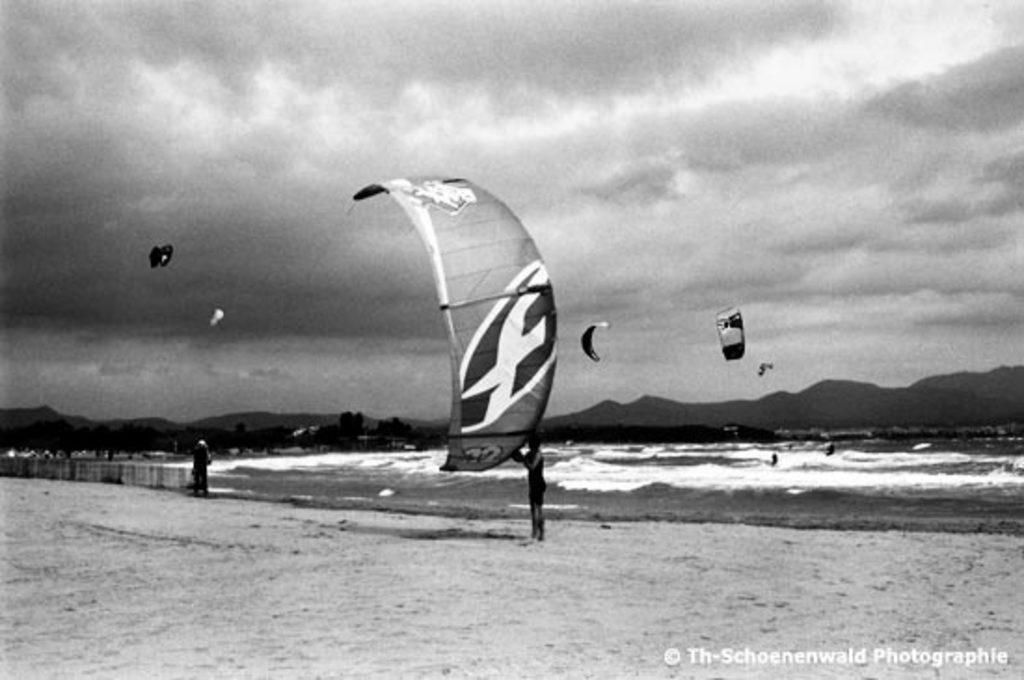Can you describe this image briefly? This is a black and white image. On the bottom right, there is a watermark. In the middle of this image, there is a person, standing on a sand surface and holding a parachute. On the left side, there is a person standing. In the background, there are parachutes in the air, there are persons in the water of the ocean, there are trees, mountains and there are clouds in the sky. 